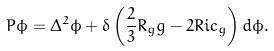Convert formula to latex. <formula><loc_0><loc_0><loc_500><loc_500>P \phi = \Delta ^ { 2 } \phi + \delta \left ( \frac { 2 } { 3 } R _ { g } g - 2 R i c _ { g } \right ) d \phi .</formula> 